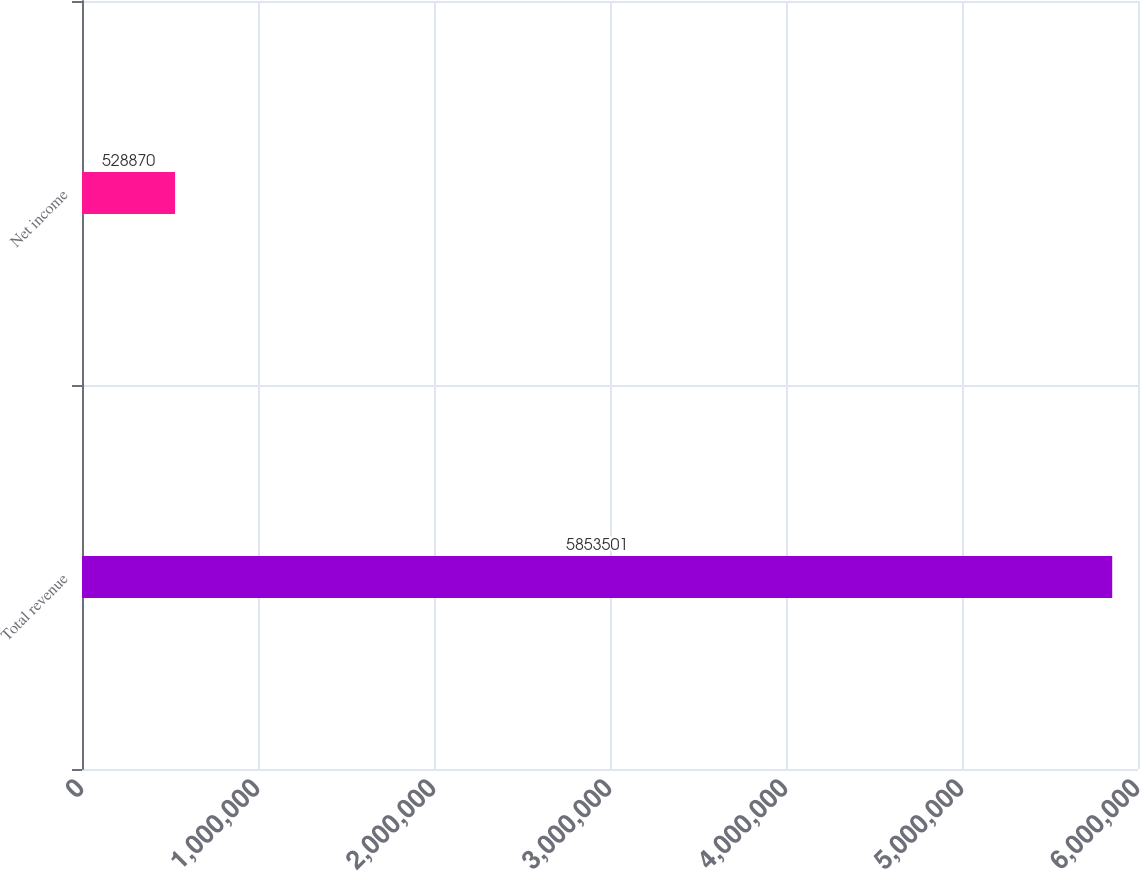Convert chart to OTSL. <chart><loc_0><loc_0><loc_500><loc_500><bar_chart><fcel>Total revenue<fcel>Net income<nl><fcel>5.8535e+06<fcel>528870<nl></chart> 